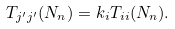Convert formula to latex. <formula><loc_0><loc_0><loc_500><loc_500>T _ { j ^ { \prime } j ^ { \prime } } ( N _ { n } ) = k _ { i } T _ { i i } ( N _ { n } ) .</formula> 